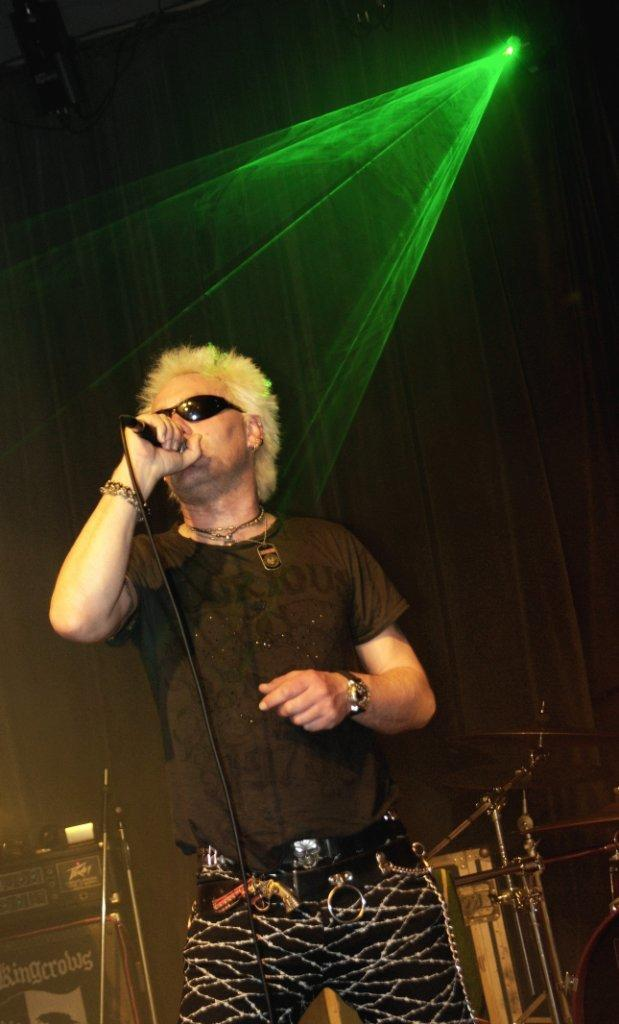What is the man doing on the stage in the image? The man is singing on the stage in the image. What is the man holding while singing? The man is holding a microphone in his hand. Can you describe the man's appearance in the image? The man is wearing spectacles. What can be seen in the background of the image? There is a light in the background of the image. What is the baby's name who was born during the man's performance in the image? There is no baby or birth event mentioned or depicted in the image; it only shows a man singing on stage with a microphone. 